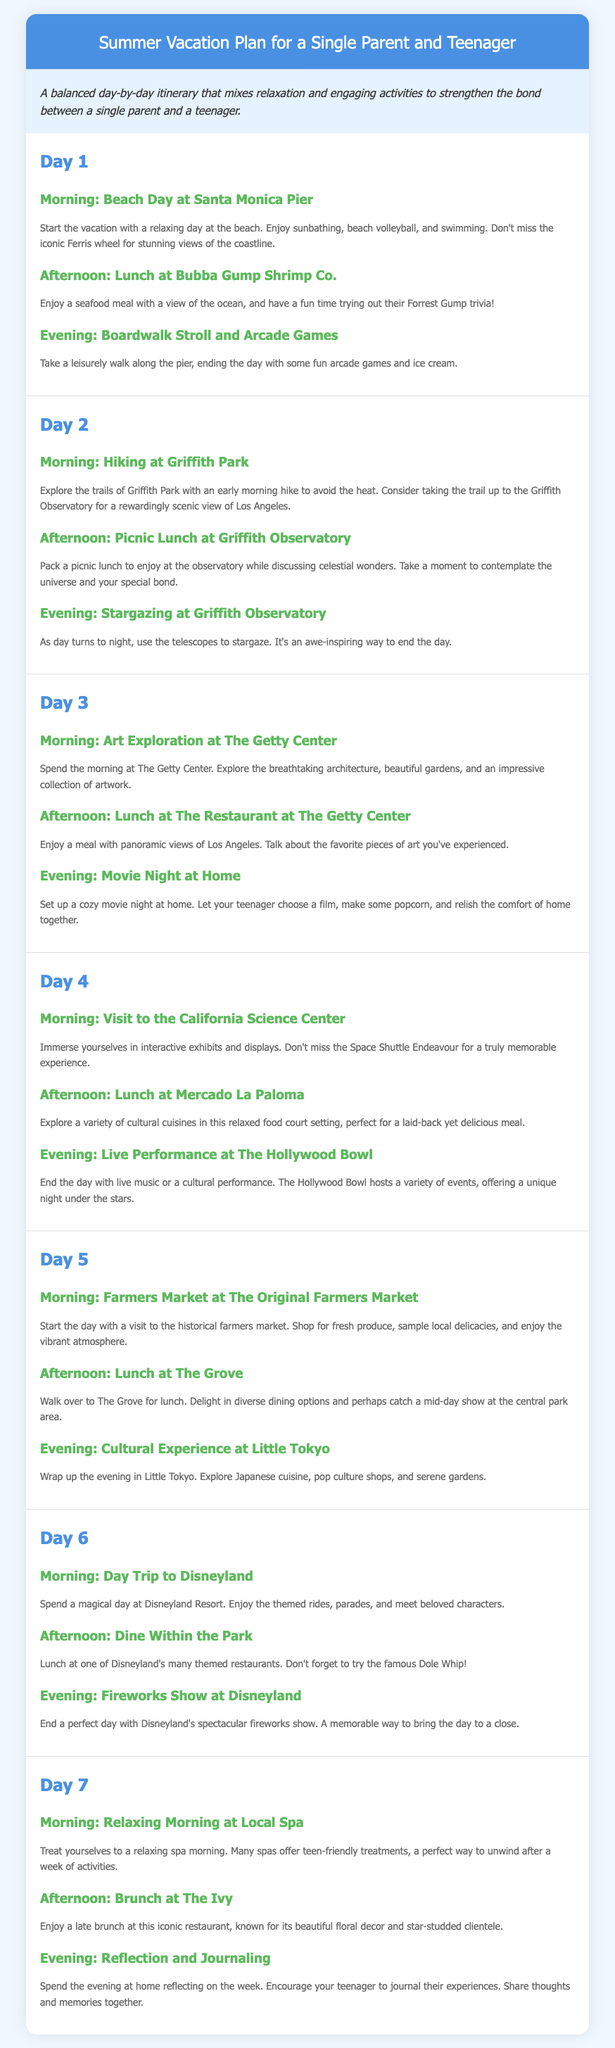what is the title of the document? The title is specified in the `<title>` tag, which describes the content of the itinerary as a summer vacation plan for a single parent and teenager.
Answer: Summer Vacation Plan for a Single Parent and Teenager how many days does the itinerary cover? The document outlines daily activities for a total of seven days.
Answer: 7 what activity is planned for the morning of Day 3? The morning activity on Day 3 is outlined in the "day" section, specifying an art exploration at The Getty Center.
Answer: Art Exploration at The Getty Center what is the main evening activity on Day 4? The evening activity of Day 4 mentions a live performance at The Hollywood Bowl.
Answer: Live Performance at The Hollywood Bowl which day includes a visit to Disneyland? The document indicates that Day 6 is dedicated to a day trip to Disneyland.
Answer: Day 6 what type of experience is planned for the evening of Day 7? The evening of Day 7 focuses on reflection and journaling, allowing for a moment of connection post-vacation.
Answer: Reflection and Journaling what meal is suggested after the hiking on Day 2? The afternoon activity of Day 2 recommends a picnic lunch at Griffith Observatory after the morning hike.
Answer: Picnic Lunch at Griffith Observatory which two places are highlighted for lunch on Day 5? The two lunch places mentioned in Day 5 are The Grove and Mercado La Paloma, providing a variety of dining experiences.
Answer: The Grove, Mercado La Paloma 